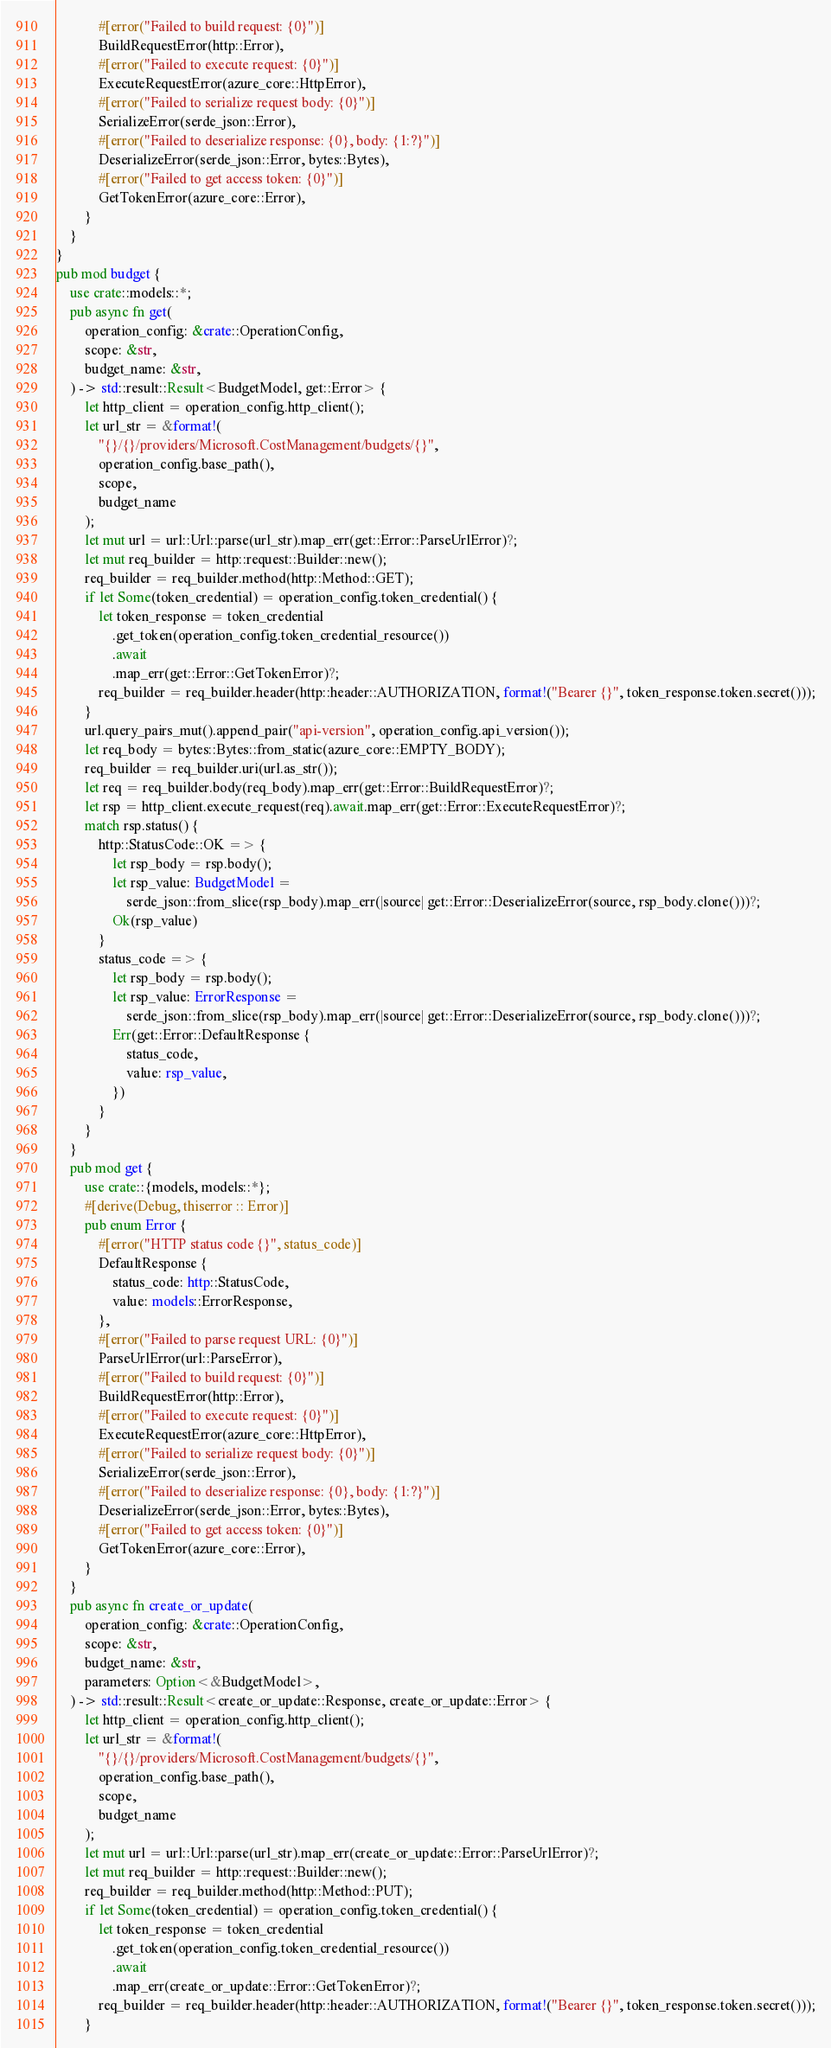<code> <loc_0><loc_0><loc_500><loc_500><_Rust_>            #[error("Failed to build request: {0}")]
            BuildRequestError(http::Error),
            #[error("Failed to execute request: {0}")]
            ExecuteRequestError(azure_core::HttpError),
            #[error("Failed to serialize request body: {0}")]
            SerializeError(serde_json::Error),
            #[error("Failed to deserialize response: {0}, body: {1:?}")]
            DeserializeError(serde_json::Error, bytes::Bytes),
            #[error("Failed to get access token: {0}")]
            GetTokenError(azure_core::Error),
        }
    }
}
pub mod budget {
    use crate::models::*;
    pub async fn get(
        operation_config: &crate::OperationConfig,
        scope: &str,
        budget_name: &str,
    ) -> std::result::Result<BudgetModel, get::Error> {
        let http_client = operation_config.http_client();
        let url_str = &format!(
            "{}/{}/providers/Microsoft.CostManagement/budgets/{}",
            operation_config.base_path(),
            scope,
            budget_name
        );
        let mut url = url::Url::parse(url_str).map_err(get::Error::ParseUrlError)?;
        let mut req_builder = http::request::Builder::new();
        req_builder = req_builder.method(http::Method::GET);
        if let Some(token_credential) = operation_config.token_credential() {
            let token_response = token_credential
                .get_token(operation_config.token_credential_resource())
                .await
                .map_err(get::Error::GetTokenError)?;
            req_builder = req_builder.header(http::header::AUTHORIZATION, format!("Bearer {}", token_response.token.secret()));
        }
        url.query_pairs_mut().append_pair("api-version", operation_config.api_version());
        let req_body = bytes::Bytes::from_static(azure_core::EMPTY_BODY);
        req_builder = req_builder.uri(url.as_str());
        let req = req_builder.body(req_body).map_err(get::Error::BuildRequestError)?;
        let rsp = http_client.execute_request(req).await.map_err(get::Error::ExecuteRequestError)?;
        match rsp.status() {
            http::StatusCode::OK => {
                let rsp_body = rsp.body();
                let rsp_value: BudgetModel =
                    serde_json::from_slice(rsp_body).map_err(|source| get::Error::DeserializeError(source, rsp_body.clone()))?;
                Ok(rsp_value)
            }
            status_code => {
                let rsp_body = rsp.body();
                let rsp_value: ErrorResponse =
                    serde_json::from_slice(rsp_body).map_err(|source| get::Error::DeserializeError(source, rsp_body.clone()))?;
                Err(get::Error::DefaultResponse {
                    status_code,
                    value: rsp_value,
                })
            }
        }
    }
    pub mod get {
        use crate::{models, models::*};
        #[derive(Debug, thiserror :: Error)]
        pub enum Error {
            #[error("HTTP status code {}", status_code)]
            DefaultResponse {
                status_code: http::StatusCode,
                value: models::ErrorResponse,
            },
            #[error("Failed to parse request URL: {0}")]
            ParseUrlError(url::ParseError),
            #[error("Failed to build request: {0}")]
            BuildRequestError(http::Error),
            #[error("Failed to execute request: {0}")]
            ExecuteRequestError(azure_core::HttpError),
            #[error("Failed to serialize request body: {0}")]
            SerializeError(serde_json::Error),
            #[error("Failed to deserialize response: {0}, body: {1:?}")]
            DeserializeError(serde_json::Error, bytes::Bytes),
            #[error("Failed to get access token: {0}")]
            GetTokenError(azure_core::Error),
        }
    }
    pub async fn create_or_update(
        operation_config: &crate::OperationConfig,
        scope: &str,
        budget_name: &str,
        parameters: Option<&BudgetModel>,
    ) -> std::result::Result<create_or_update::Response, create_or_update::Error> {
        let http_client = operation_config.http_client();
        let url_str = &format!(
            "{}/{}/providers/Microsoft.CostManagement/budgets/{}",
            operation_config.base_path(),
            scope,
            budget_name
        );
        let mut url = url::Url::parse(url_str).map_err(create_or_update::Error::ParseUrlError)?;
        let mut req_builder = http::request::Builder::new();
        req_builder = req_builder.method(http::Method::PUT);
        if let Some(token_credential) = operation_config.token_credential() {
            let token_response = token_credential
                .get_token(operation_config.token_credential_resource())
                .await
                .map_err(create_or_update::Error::GetTokenError)?;
            req_builder = req_builder.header(http::header::AUTHORIZATION, format!("Bearer {}", token_response.token.secret()));
        }</code> 